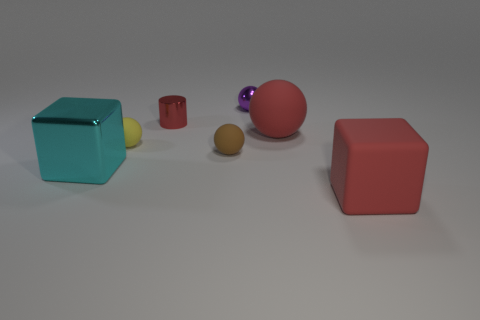Add 1 tiny purple matte things. How many objects exist? 8 Subtract all spheres. How many objects are left? 3 Subtract 0 green blocks. How many objects are left? 7 Subtract all blue cylinders. Subtract all small brown objects. How many objects are left? 6 Add 2 red cylinders. How many red cylinders are left? 3 Add 5 tiny brown things. How many tiny brown things exist? 6 